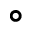<formula> <loc_0><loc_0><loc_500><loc_500>\circ</formula> 